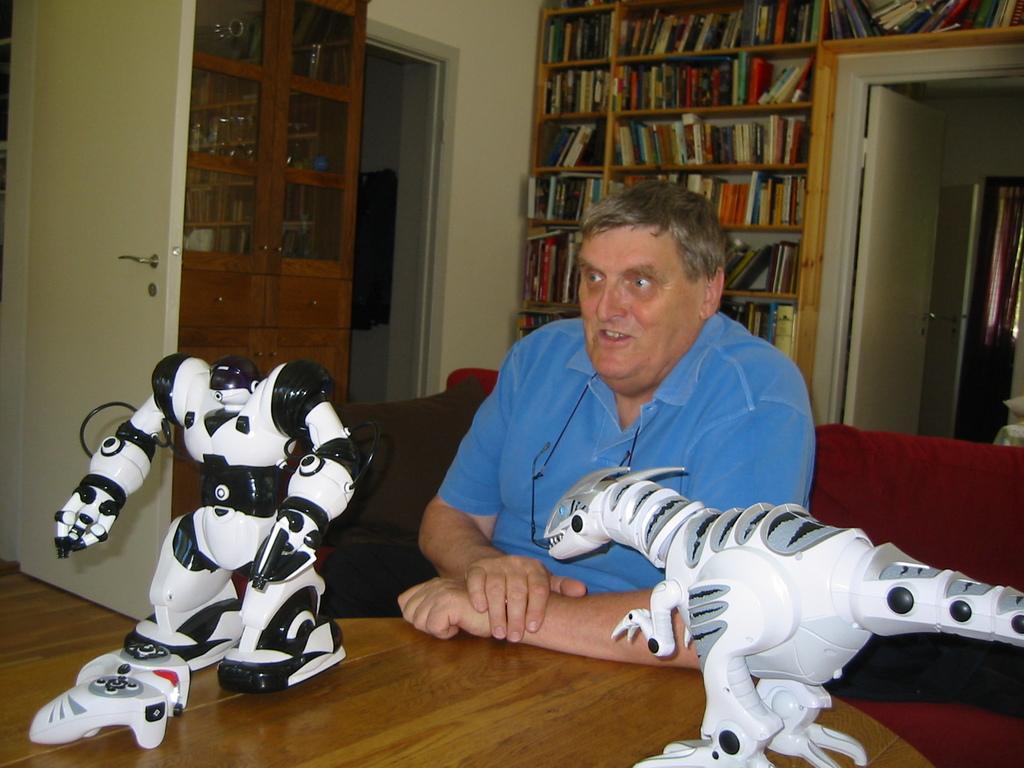How would you summarize this image in a sentence or two? In this image I can see the person sitting on the couch and there is a table in-front of the person. On the table I can see the toys. In the background I can see the books in the rack. To the left I can see the door and the few objects in the cupboard. To the right I can see an another door and the curtain. 